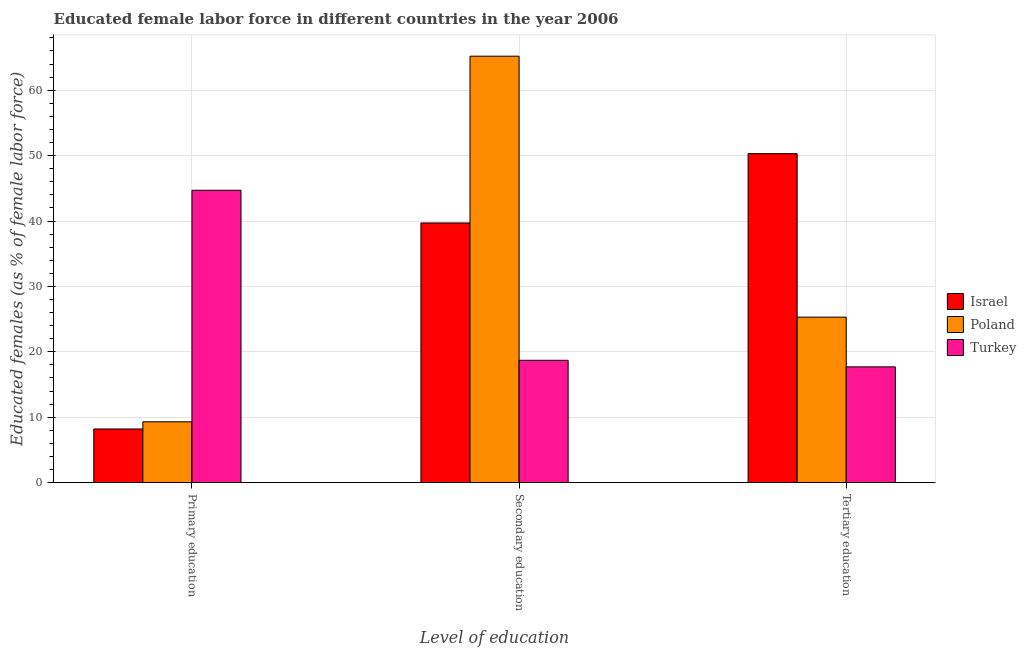How many groups of bars are there?
Your answer should be compact. 3. Are the number of bars per tick equal to the number of legend labels?
Keep it short and to the point. Yes. Are the number of bars on each tick of the X-axis equal?
Give a very brief answer. Yes. What is the label of the 2nd group of bars from the left?
Provide a succinct answer. Secondary education. What is the percentage of female labor force who received tertiary education in Turkey?
Offer a terse response. 17.7. Across all countries, what is the maximum percentage of female labor force who received secondary education?
Your answer should be very brief. 65.2. Across all countries, what is the minimum percentage of female labor force who received secondary education?
Keep it short and to the point. 18.7. What is the total percentage of female labor force who received primary education in the graph?
Provide a short and direct response. 62.2. What is the difference between the percentage of female labor force who received secondary education in Turkey and that in Poland?
Your answer should be very brief. -46.5. What is the difference between the percentage of female labor force who received tertiary education in Poland and the percentage of female labor force who received secondary education in Turkey?
Your answer should be compact. 6.6. What is the average percentage of female labor force who received tertiary education per country?
Keep it short and to the point. 31.1. What is the difference between the percentage of female labor force who received tertiary education and percentage of female labor force who received secondary education in Israel?
Make the answer very short. 10.6. What is the ratio of the percentage of female labor force who received tertiary education in Israel to that in Turkey?
Your answer should be compact. 2.84. What is the difference between the highest and the second highest percentage of female labor force who received tertiary education?
Provide a succinct answer. 25. What is the difference between the highest and the lowest percentage of female labor force who received tertiary education?
Keep it short and to the point. 32.6. In how many countries, is the percentage of female labor force who received tertiary education greater than the average percentage of female labor force who received tertiary education taken over all countries?
Offer a terse response. 1. Is the sum of the percentage of female labor force who received secondary education in Poland and Israel greater than the maximum percentage of female labor force who received tertiary education across all countries?
Provide a short and direct response. Yes. What does the 2nd bar from the right in Primary education represents?
Provide a short and direct response. Poland. How many bars are there?
Offer a very short reply. 9. How many countries are there in the graph?
Your answer should be very brief. 3. Does the graph contain any zero values?
Your response must be concise. No. Where does the legend appear in the graph?
Your answer should be very brief. Center right. How many legend labels are there?
Keep it short and to the point. 3. What is the title of the graph?
Ensure brevity in your answer.  Educated female labor force in different countries in the year 2006. What is the label or title of the X-axis?
Ensure brevity in your answer.  Level of education. What is the label or title of the Y-axis?
Provide a succinct answer. Educated females (as % of female labor force). What is the Educated females (as % of female labor force) of Israel in Primary education?
Provide a succinct answer. 8.2. What is the Educated females (as % of female labor force) of Poland in Primary education?
Give a very brief answer. 9.3. What is the Educated females (as % of female labor force) of Turkey in Primary education?
Your answer should be compact. 44.7. What is the Educated females (as % of female labor force) in Israel in Secondary education?
Offer a terse response. 39.7. What is the Educated females (as % of female labor force) of Poland in Secondary education?
Make the answer very short. 65.2. What is the Educated females (as % of female labor force) of Turkey in Secondary education?
Give a very brief answer. 18.7. What is the Educated females (as % of female labor force) of Israel in Tertiary education?
Give a very brief answer. 50.3. What is the Educated females (as % of female labor force) in Poland in Tertiary education?
Keep it short and to the point. 25.3. What is the Educated females (as % of female labor force) of Turkey in Tertiary education?
Make the answer very short. 17.7. Across all Level of education, what is the maximum Educated females (as % of female labor force) in Israel?
Your answer should be compact. 50.3. Across all Level of education, what is the maximum Educated females (as % of female labor force) in Poland?
Give a very brief answer. 65.2. Across all Level of education, what is the maximum Educated females (as % of female labor force) in Turkey?
Offer a very short reply. 44.7. Across all Level of education, what is the minimum Educated females (as % of female labor force) of Israel?
Your answer should be compact. 8.2. Across all Level of education, what is the minimum Educated females (as % of female labor force) of Poland?
Offer a terse response. 9.3. Across all Level of education, what is the minimum Educated females (as % of female labor force) of Turkey?
Provide a short and direct response. 17.7. What is the total Educated females (as % of female labor force) of Israel in the graph?
Your answer should be very brief. 98.2. What is the total Educated females (as % of female labor force) in Poland in the graph?
Your response must be concise. 99.8. What is the total Educated females (as % of female labor force) in Turkey in the graph?
Provide a succinct answer. 81.1. What is the difference between the Educated females (as % of female labor force) of Israel in Primary education and that in Secondary education?
Your answer should be compact. -31.5. What is the difference between the Educated females (as % of female labor force) in Poland in Primary education and that in Secondary education?
Ensure brevity in your answer.  -55.9. What is the difference between the Educated females (as % of female labor force) in Israel in Primary education and that in Tertiary education?
Provide a short and direct response. -42.1. What is the difference between the Educated females (as % of female labor force) in Poland in Primary education and that in Tertiary education?
Ensure brevity in your answer.  -16. What is the difference between the Educated females (as % of female labor force) in Turkey in Primary education and that in Tertiary education?
Your answer should be very brief. 27. What is the difference between the Educated females (as % of female labor force) of Poland in Secondary education and that in Tertiary education?
Your answer should be very brief. 39.9. What is the difference between the Educated females (as % of female labor force) in Israel in Primary education and the Educated females (as % of female labor force) in Poland in Secondary education?
Keep it short and to the point. -57. What is the difference between the Educated females (as % of female labor force) in Israel in Primary education and the Educated females (as % of female labor force) in Turkey in Secondary education?
Your response must be concise. -10.5. What is the difference between the Educated females (as % of female labor force) of Poland in Primary education and the Educated females (as % of female labor force) of Turkey in Secondary education?
Provide a succinct answer. -9.4. What is the difference between the Educated females (as % of female labor force) in Israel in Primary education and the Educated females (as % of female labor force) in Poland in Tertiary education?
Provide a succinct answer. -17.1. What is the difference between the Educated females (as % of female labor force) in Israel in Primary education and the Educated females (as % of female labor force) in Turkey in Tertiary education?
Ensure brevity in your answer.  -9.5. What is the difference between the Educated females (as % of female labor force) in Israel in Secondary education and the Educated females (as % of female labor force) in Poland in Tertiary education?
Provide a succinct answer. 14.4. What is the difference between the Educated females (as % of female labor force) in Israel in Secondary education and the Educated females (as % of female labor force) in Turkey in Tertiary education?
Give a very brief answer. 22. What is the difference between the Educated females (as % of female labor force) of Poland in Secondary education and the Educated females (as % of female labor force) of Turkey in Tertiary education?
Make the answer very short. 47.5. What is the average Educated females (as % of female labor force) of Israel per Level of education?
Your answer should be very brief. 32.73. What is the average Educated females (as % of female labor force) in Poland per Level of education?
Provide a succinct answer. 33.27. What is the average Educated females (as % of female labor force) of Turkey per Level of education?
Provide a short and direct response. 27.03. What is the difference between the Educated females (as % of female labor force) in Israel and Educated females (as % of female labor force) in Poland in Primary education?
Offer a very short reply. -1.1. What is the difference between the Educated females (as % of female labor force) of Israel and Educated females (as % of female labor force) of Turkey in Primary education?
Give a very brief answer. -36.5. What is the difference between the Educated females (as % of female labor force) of Poland and Educated females (as % of female labor force) of Turkey in Primary education?
Offer a terse response. -35.4. What is the difference between the Educated females (as % of female labor force) of Israel and Educated females (as % of female labor force) of Poland in Secondary education?
Give a very brief answer. -25.5. What is the difference between the Educated females (as % of female labor force) of Poland and Educated females (as % of female labor force) of Turkey in Secondary education?
Give a very brief answer. 46.5. What is the difference between the Educated females (as % of female labor force) of Israel and Educated females (as % of female labor force) of Poland in Tertiary education?
Make the answer very short. 25. What is the difference between the Educated females (as % of female labor force) in Israel and Educated females (as % of female labor force) in Turkey in Tertiary education?
Offer a very short reply. 32.6. What is the ratio of the Educated females (as % of female labor force) of Israel in Primary education to that in Secondary education?
Make the answer very short. 0.21. What is the ratio of the Educated females (as % of female labor force) in Poland in Primary education to that in Secondary education?
Give a very brief answer. 0.14. What is the ratio of the Educated females (as % of female labor force) in Turkey in Primary education to that in Secondary education?
Your answer should be compact. 2.39. What is the ratio of the Educated females (as % of female labor force) of Israel in Primary education to that in Tertiary education?
Your answer should be compact. 0.16. What is the ratio of the Educated females (as % of female labor force) in Poland in Primary education to that in Tertiary education?
Provide a succinct answer. 0.37. What is the ratio of the Educated females (as % of female labor force) in Turkey in Primary education to that in Tertiary education?
Your answer should be compact. 2.53. What is the ratio of the Educated females (as % of female labor force) of Israel in Secondary education to that in Tertiary education?
Provide a succinct answer. 0.79. What is the ratio of the Educated females (as % of female labor force) of Poland in Secondary education to that in Tertiary education?
Your answer should be compact. 2.58. What is the ratio of the Educated females (as % of female labor force) of Turkey in Secondary education to that in Tertiary education?
Your answer should be compact. 1.06. What is the difference between the highest and the second highest Educated females (as % of female labor force) in Israel?
Offer a very short reply. 10.6. What is the difference between the highest and the second highest Educated females (as % of female labor force) of Poland?
Your answer should be compact. 39.9. What is the difference between the highest and the lowest Educated females (as % of female labor force) of Israel?
Make the answer very short. 42.1. What is the difference between the highest and the lowest Educated females (as % of female labor force) of Poland?
Give a very brief answer. 55.9. What is the difference between the highest and the lowest Educated females (as % of female labor force) in Turkey?
Provide a succinct answer. 27. 